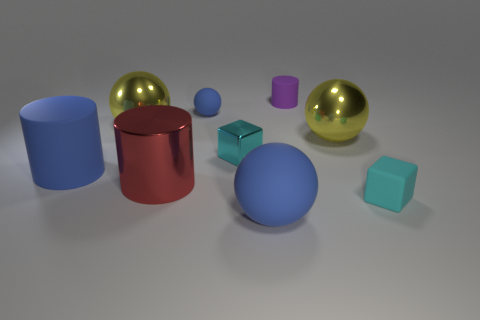How many cyan cubes must be subtracted to get 1 cyan cubes? 1 Subtract all red cylinders. How many yellow balls are left? 2 Subtract all tiny rubber balls. How many balls are left? 3 Subtract 2 balls. How many balls are left? 2 Subtract all brown cylinders. Subtract all brown spheres. How many cylinders are left? 3 Subtract all cubes. How many objects are left? 7 Subtract all large red cubes. Subtract all large cylinders. How many objects are left? 7 Add 5 cyan blocks. How many cyan blocks are left? 7 Add 1 large blue matte cubes. How many large blue matte cubes exist? 1 Subtract 0 green balls. How many objects are left? 9 